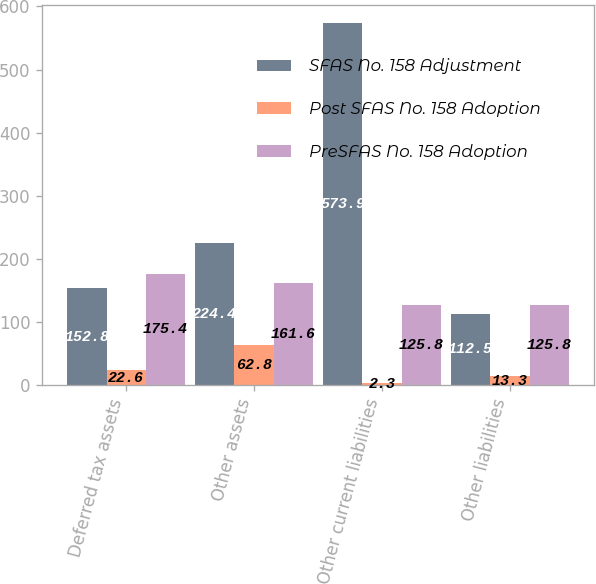<chart> <loc_0><loc_0><loc_500><loc_500><stacked_bar_chart><ecel><fcel>Deferred tax assets<fcel>Other assets<fcel>Other current liabilities<fcel>Other liabilities<nl><fcel>SFAS No. 158 Adjustment<fcel>152.8<fcel>224.4<fcel>573.9<fcel>112.5<nl><fcel>Post SFAS No. 158 Adoption<fcel>22.6<fcel>62.8<fcel>2.3<fcel>13.3<nl><fcel>PreSFAS No. 158 Adoption<fcel>175.4<fcel>161.6<fcel>125.8<fcel>125.8<nl></chart> 